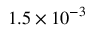Convert formula to latex. <formula><loc_0><loc_0><loc_500><loc_500>1 . 5 \times 1 0 ^ { - 3 }</formula> 